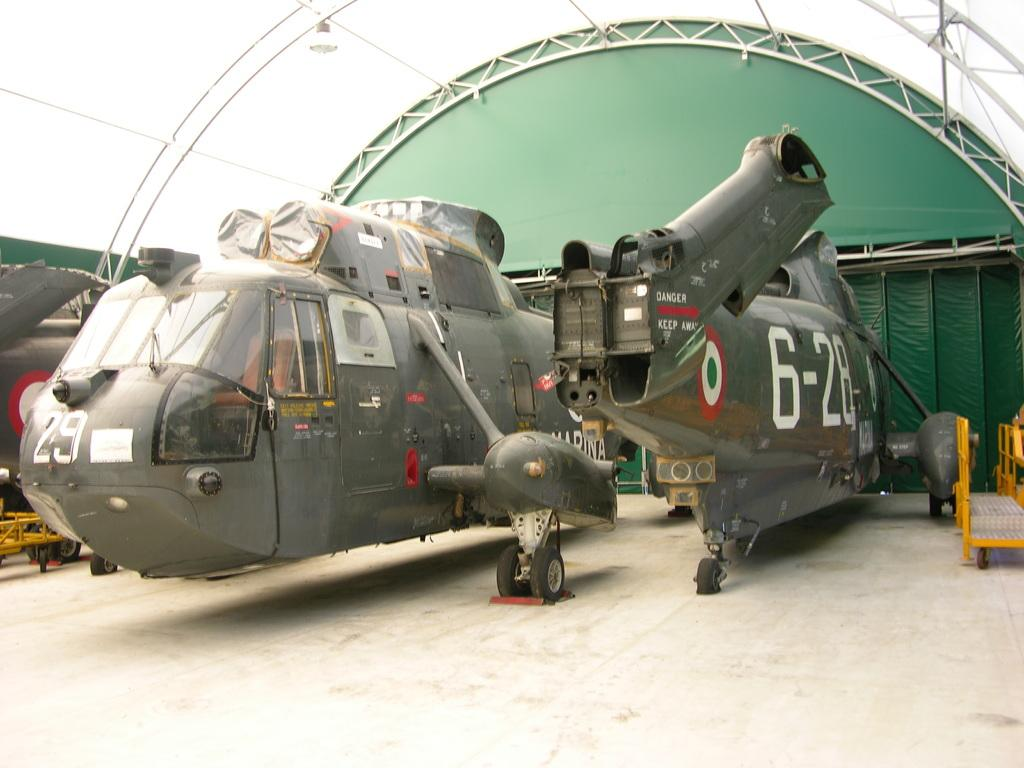<image>
Relay a brief, clear account of the picture shown. two military aircrafts labeled 29 and 6-28 parked in what looks like a hanger 